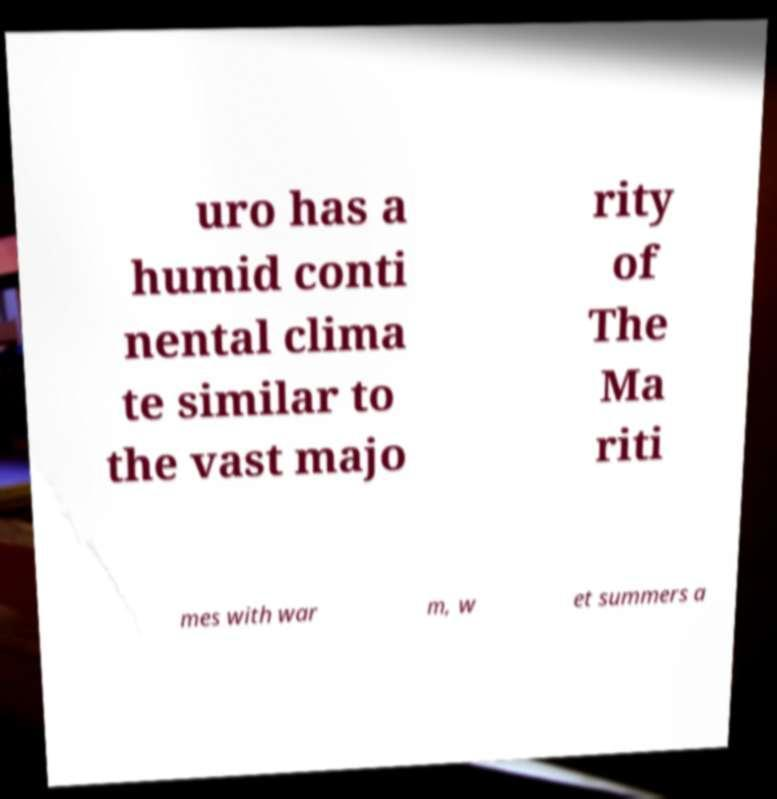Could you extract and type out the text from this image? uro has a humid conti nental clima te similar to the vast majo rity of The Ma riti mes with war m, w et summers a 